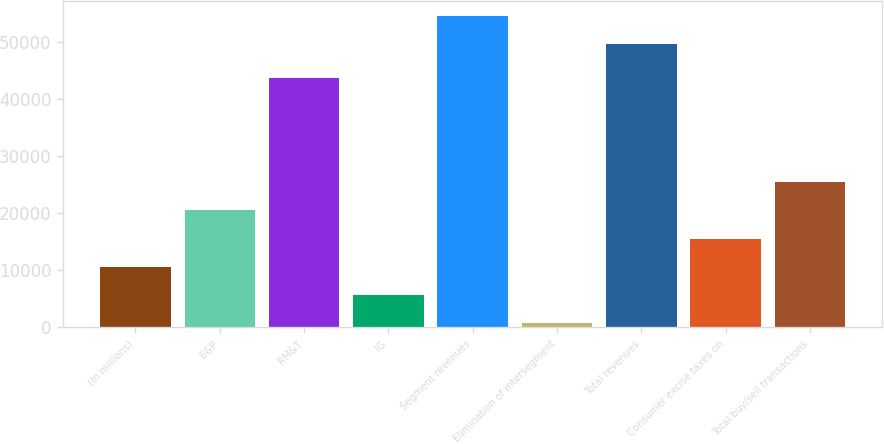Convert chart. <chart><loc_0><loc_0><loc_500><loc_500><bar_chart><fcel>(In millions)<fcel>E&P<fcel>RM&T<fcel>IG<fcel>Segment revenues<fcel>Elimination of intersegment<fcel>Total revenues<fcel>Consumer excise taxes on<fcel>Total buy/sell transactions<nl><fcel>10587.6<fcel>20507.2<fcel>43630<fcel>5627.8<fcel>54557.8<fcel>668<fcel>49598<fcel>15547.4<fcel>25467<nl></chart> 